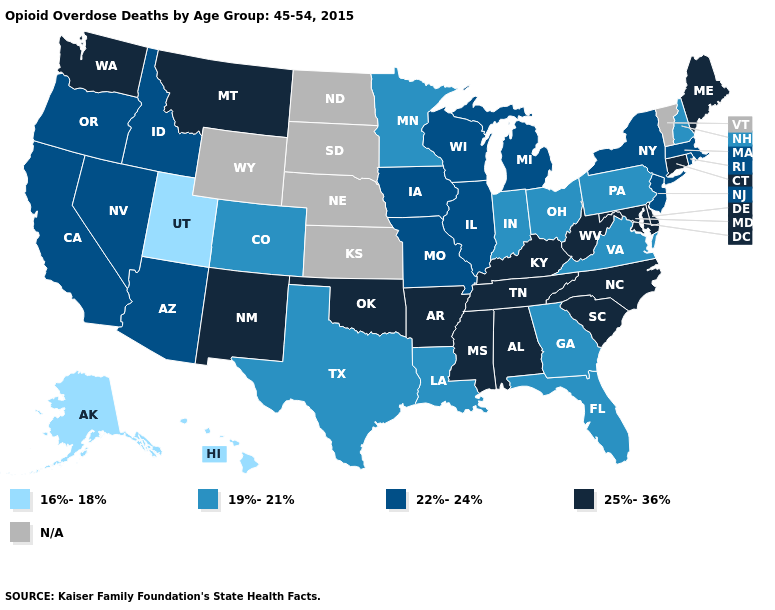Name the states that have a value in the range 25%-36%?
Keep it brief. Alabama, Arkansas, Connecticut, Delaware, Kentucky, Maine, Maryland, Mississippi, Montana, New Mexico, North Carolina, Oklahoma, South Carolina, Tennessee, Washington, West Virginia. Does Iowa have the lowest value in the MidWest?
Give a very brief answer. No. Which states have the lowest value in the Northeast?
Short answer required. New Hampshire, Pennsylvania. What is the lowest value in the USA?
Be succinct. 16%-18%. Among the states that border Pennsylvania , does New Jersey have the highest value?
Short answer required. No. Does Hawaii have the lowest value in the USA?
Keep it brief. Yes. What is the highest value in states that border Nevada?
Answer briefly. 22%-24%. What is the highest value in the Northeast ?
Quick response, please. 25%-36%. Which states have the highest value in the USA?
Concise answer only. Alabama, Arkansas, Connecticut, Delaware, Kentucky, Maine, Maryland, Mississippi, Montana, New Mexico, North Carolina, Oklahoma, South Carolina, Tennessee, Washington, West Virginia. What is the value of South Carolina?
Write a very short answer. 25%-36%. What is the value of Kentucky?
Give a very brief answer. 25%-36%. What is the highest value in the MidWest ?
Answer briefly. 22%-24%. Among the states that border Texas , which have the highest value?
Keep it brief. Arkansas, New Mexico, Oklahoma. What is the lowest value in states that border Oklahoma?
Keep it brief. 19%-21%. 